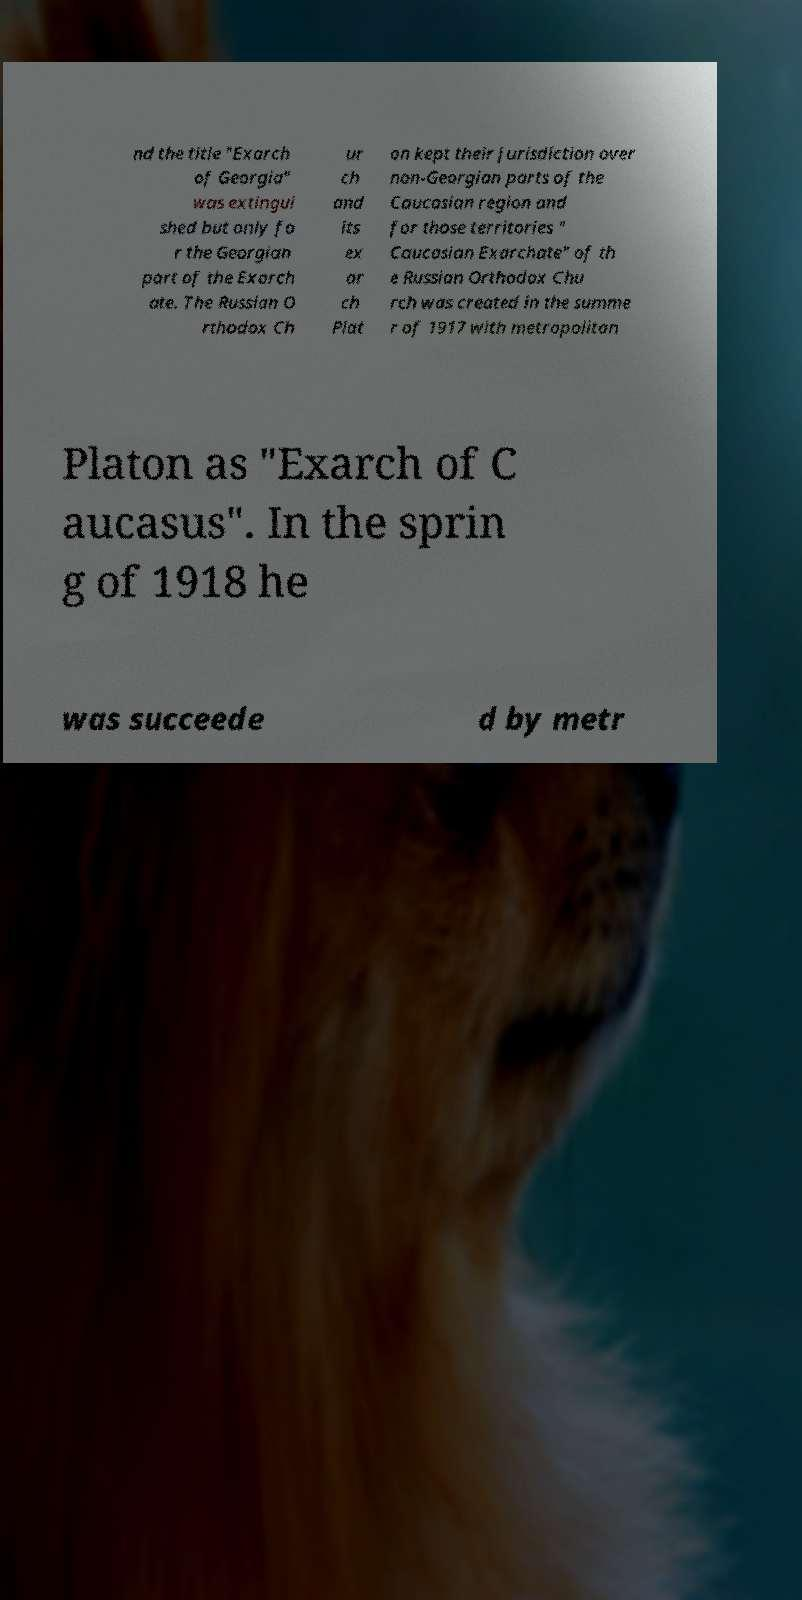Please identify and transcribe the text found in this image. nd the title "Exarch of Georgia" was extingui shed but only fo r the Georgian part of the Exarch ate. The Russian O rthodox Ch ur ch and its ex ar ch Plat on kept their jurisdiction over non-Georgian parts of the Caucasian region and for those territories " Caucasian Exarchate" of th e Russian Orthodox Chu rch was created in the summe r of 1917 with metropolitan Platon as "Exarch of C aucasus". In the sprin g of 1918 he was succeede d by metr 